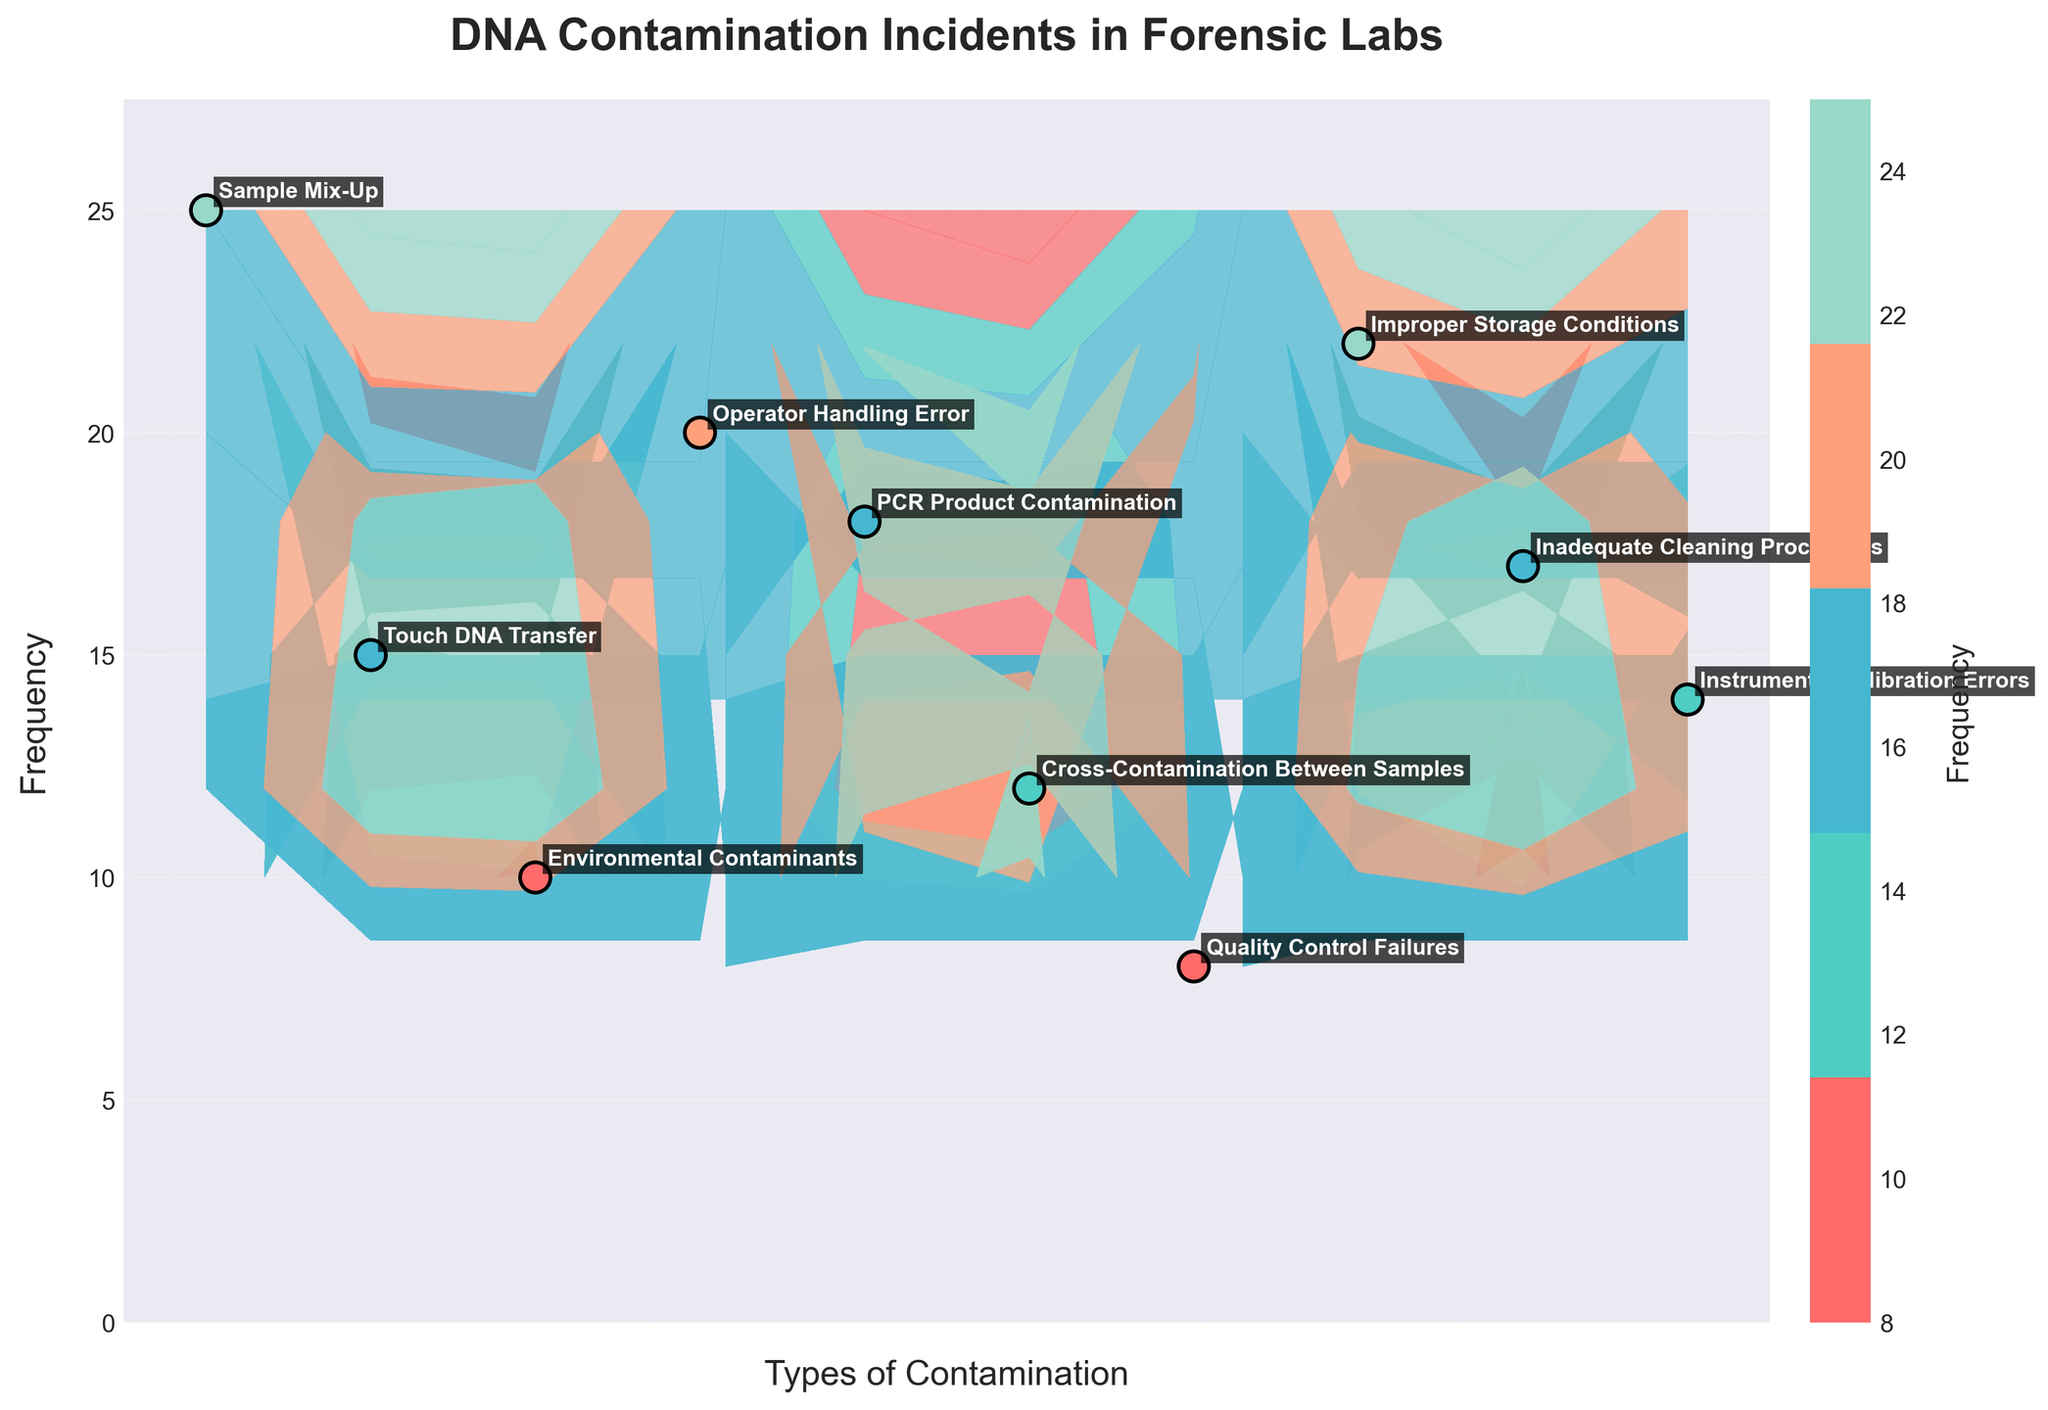What is the title of the figure? The title of the figure is displayed at the top and reads "DNA Contamination Incidents in Forensic Labs".
Answer: DNA Contamination Incidents in Forensic Labs How many types of contamination are depicted in this figure? Each labeled point on the plot represents a type of contamination. Counting these points, we see there are 10 types.
Answer: 10 Which type of contamination has the highest frequency and what is its value? The frequency values are annotated next to each type of contamination. "Sample Mix-Up" has the highest frequency with a value of 25.
Answer: Sample Mix-Up, 25 What is the frequency of "Operator Handling Error" and how does it compare to "Touch DNA Transfer"? "Operator Handling Error" has a frequency of 20 and "Touch DNA Transfer" has a frequency of 15. The difference between them is 20 - 15 = 5.
Answer: 20; It is 5 higher Which lab reported incidents related to "Improper Storage Conditions"? The annotation next to "Improper Storage Conditions" indicates that it is reported by "West Yorkshire Police DNA Test Lab".
Answer: West Yorkshire Police DNA Test Lab Calculate the average frequency of contamination incidents across all forensic labs. The frequencies are 25, 15, 10, 20, 18, 12, 8, 22, 17, and 14. Summing these, we get 161. There are 10 types of contamination, so the average frequency is 161/10 = 16.1.
Answer: 16.1 How many contamination types have a frequency greater than 15? By inspecting the frequencies, we find that there are 5 types with frequencies greater than 15 (25, 20, 18, 22, 17).
Answer: 5 Which contamination type is the closest to the average frequency and what is its frequency? The average frequency is 16.1. The closest to this average is "Improper Storage Conditions" with a frequency of 17.
Answer: Improper Storage Conditions, 17 Describe the color pattern used in the scatter plot for representing frequency. The scatter points are colored using a gradient scale, ranging from shades of red for lower frequencies to shades of cyan and green for higher frequencies. This helps visually distinguish the frequency values.
Answer: Gradient from red to cyan/green What is the frequency range represented in the contour plot and scatter plot combined? The lowest frequency on the plot is 8 and the highest is 25, thus the range is from 8 to 25.
Answer: 8 to 25 